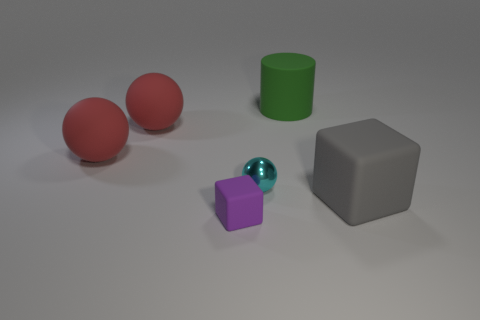Add 2 red things. How many objects exist? 8 Subtract all cylinders. How many objects are left? 5 Add 3 purple rubber cubes. How many purple rubber cubes are left? 4 Add 5 large red metallic cylinders. How many large red metallic cylinders exist? 5 Subtract 0 gray spheres. How many objects are left? 6 Subtract all gray cylinders. Subtract all big matte spheres. How many objects are left? 4 